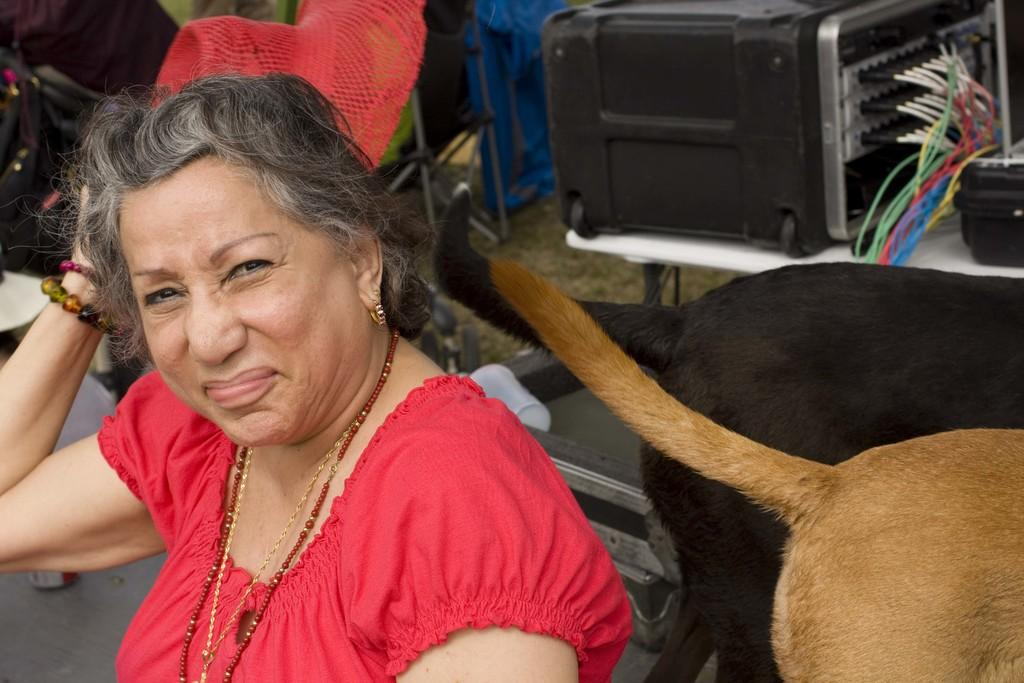Who is the main subject in the image? There is a woman in the center of the image. What animals are on the right side of the image? There are dogs on the right side of the image. What can be seen in the background of the image? There is a table and a suitcase in the background of the image, along with some other objects. What type of collar is the woman wearing in the image? There is no collar visible on the woman in the image. How many cows are present in the image? There are no cows present in the image; it features a woman and dogs. 